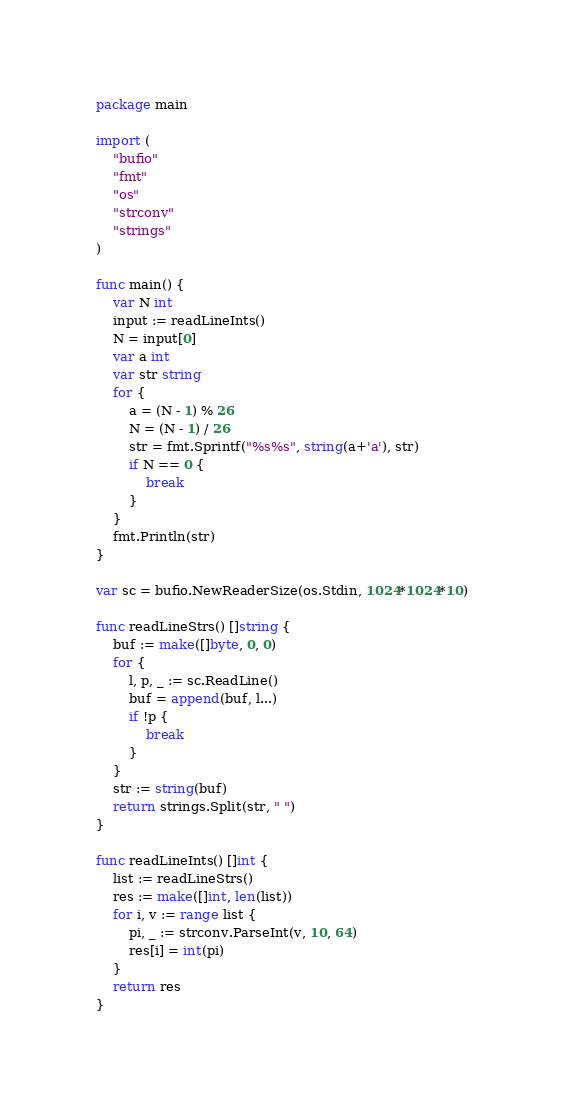Convert code to text. <code><loc_0><loc_0><loc_500><loc_500><_Go_>package main

import (
	"bufio"
	"fmt"
	"os"
	"strconv"
	"strings"
)

func main() {
	var N int
	input := readLineInts()
	N = input[0]
	var a int
	var str string
	for {
		a = (N - 1) % 26
		N = (N - 1) / 26
		str = fmt.Sprintf("%s%s", string(a+'a'), str)
		if N == 0 {
			break
		}
	}
	fmt.Println(str)
}

var sc = bufio.NewReaderSize(os.Stdin, 1024*1024*10)

func readLineStrs() []string {
	buf := make([]byte, 0, 0)
	for {
		l, p, _ := sc.ReadLine()
		buf = append(buf, l...)
		if !p {
			break
		}
	}
	str := string(buf)
	return strings.Split(str, " ")
}

func readLineInts() []int {
	list := readLineStrs()
	res := make([]int, len(list))
	for i, v := range list {
		pi, _ := strconv.ParseInt(v, 10, 64)
		res[i] = int(pi)
	}
	return res
}
</code> 